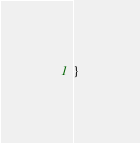<code> <loc_0><loc_0><loc_500><loc_500><_Java_>}
</code> 